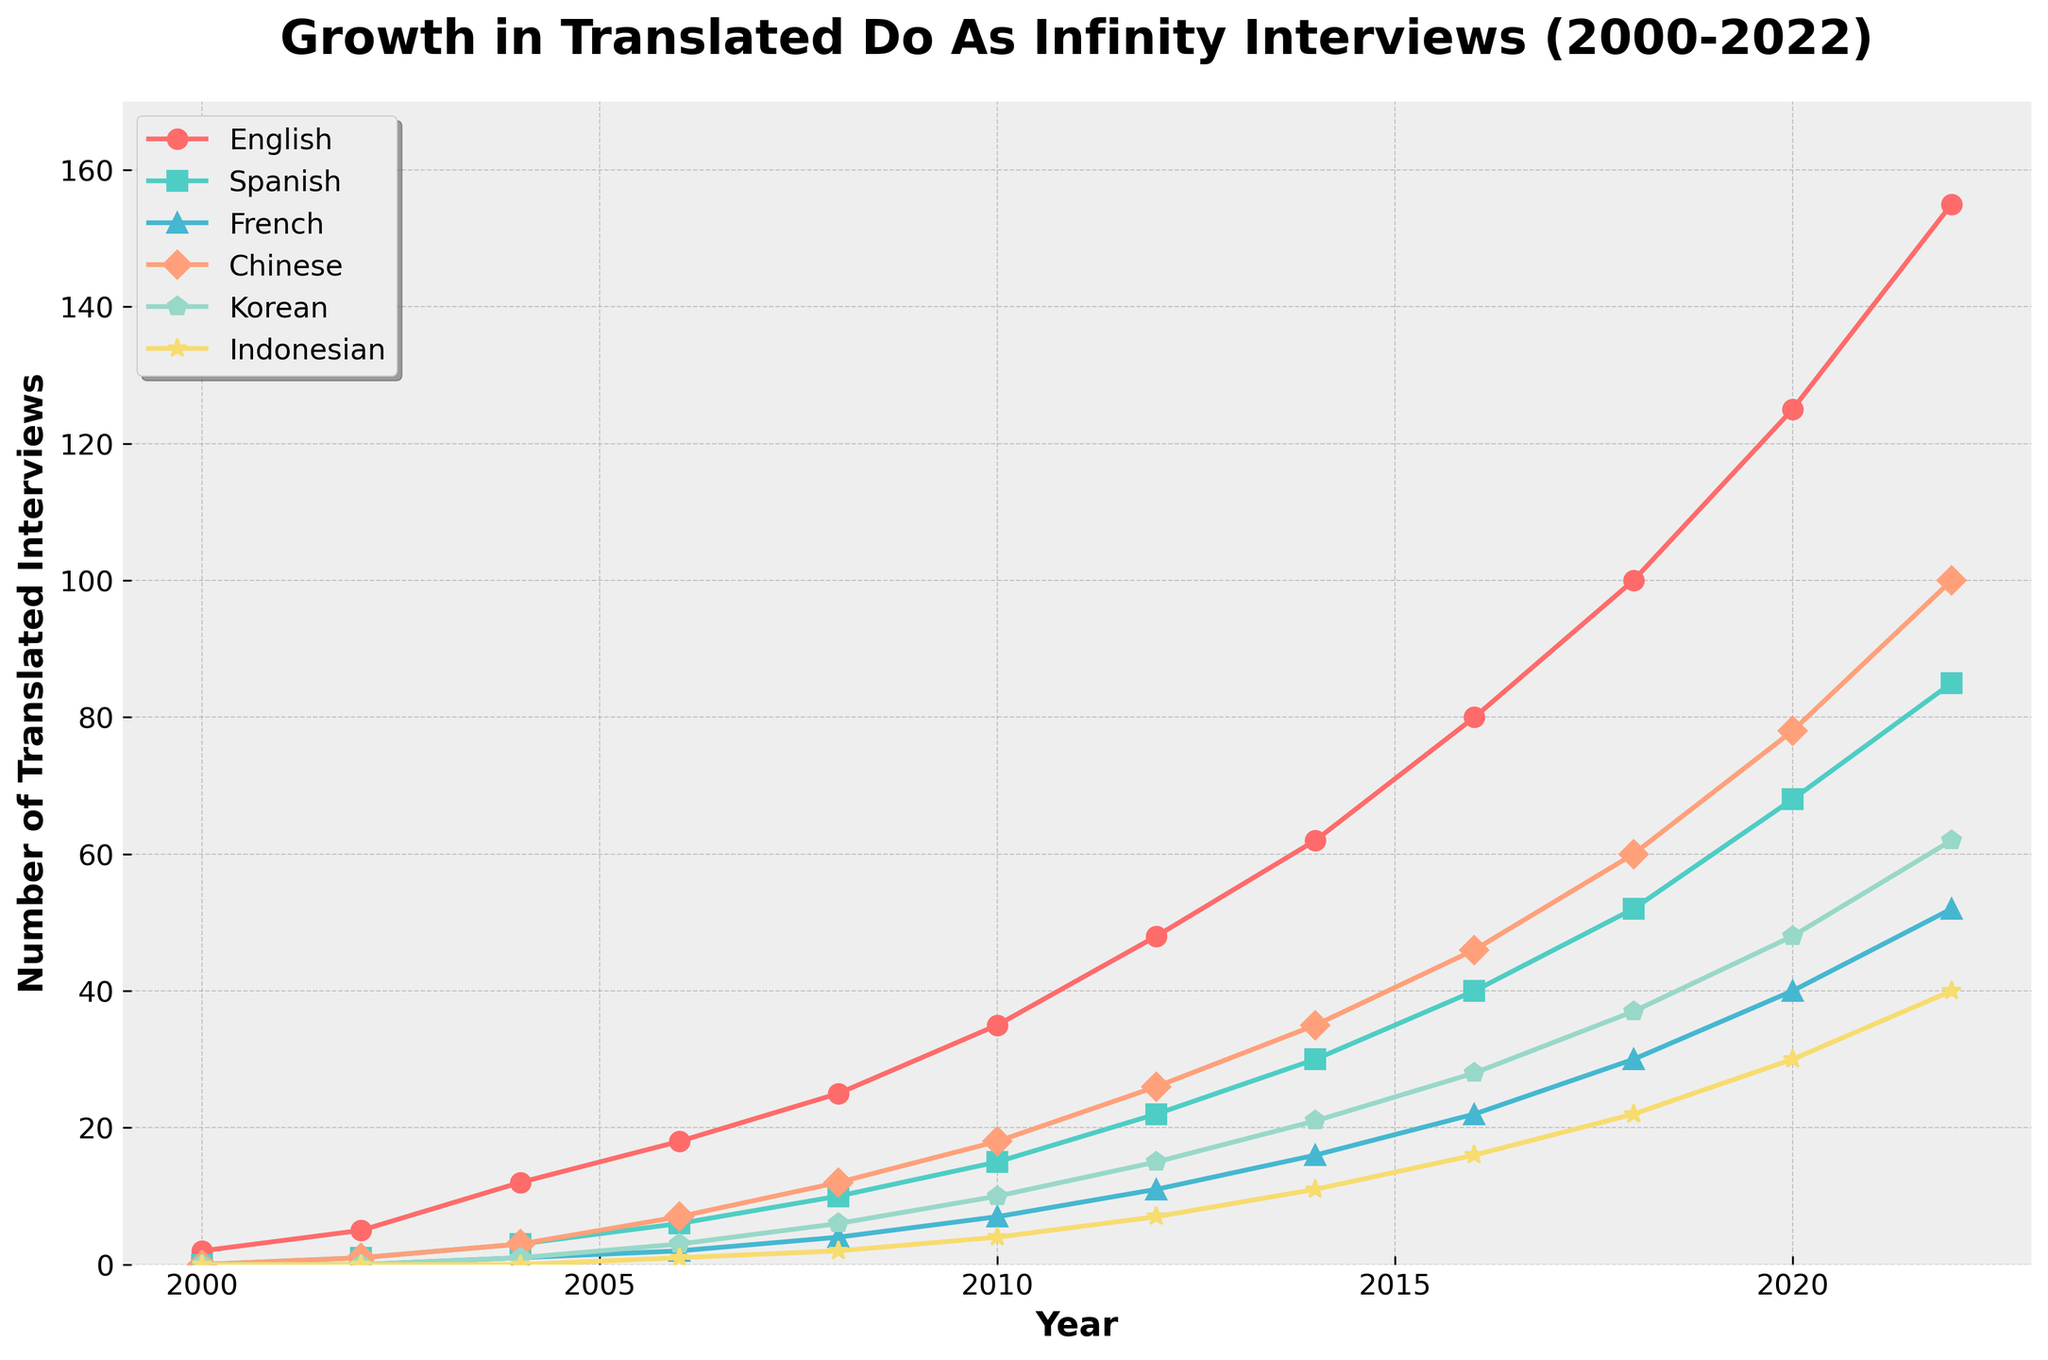How many translated interviews were available in English in 2022? Look at the value of the English series in the year 2022. The number is 155.
Answer: 155 In which year did the Korean translations first surpass 20? Identify the point where the Korean series surpasses the value of 20. This happens in 2016.
Answer: 2016 Which language saw the fastest growth between 2010 and 2020? Compare the changes in the number of translated interviews between 2010 and 2020 for each language. English went from 35 to 125, a gain of 90. Spanish went from 15 to 68, a gain of 53. French went from 7 to 40, a gain of 33. Chinese went from 18 to 78, a gain of 60. Korean went from 10 to 48, a gain of 38. Indonesian went from 4 to 30, a gain of 26. Therefore, English saw the fastest growth with an increase of 90.
Answer: English How many total translated interviews were there in 2006 across all languages? Sum the values for all languages in 2006. These values are 18 (English), 6 (Spanish), 2 (French), 7 (Chinese), 3 (Korean), and 1 (Indonesian). The total is 18 + 6 + 2 + 7 + 3 + 1 = 37.
Answer: 37 When did the total number of Spanish and French translations first exceed 50? Sum the Spanish and French translations for each year and find when the total first exceeds 50. In 2012: 22 (Spanish) + 11 (French) = 33; In 2014: 30 (Spanish) + 16 (French) = 46; In 2016: 40 (Spanish) + 22 (French) = 62. Thus, the total first exceeds 50 in 2016.
Answer: 2016 What year did the Chinese translations reach 100? Look at the data points for Chinese translations and identify when it first hits 100. This occurs in 2022.
Answer: 2022 Which language had the smallest growth from 2000 to 2006? Calculate the increase in the number of translated interviews from 2000 to 2006 for each language. English: 18 - 2 = 16; Spanish: 6 - 0 = 6; French: 2 - 0 = 2; Chinese: 7 - 0 = 7; Korean: 3 - 0 = 3; Indonesian: 1 - 0 = 1. Therefore, Indonesian had the smallest growth, with an increase of only 1.
Answer: Indonesian By how much did the number of French translated interviews change between 2004 and 2016? Subtract the number of French translations in 2004 from that in 2016. The values are 22 (in 2016) and 1 (in 2004). Thus, the change is 22 - 1 = 21.
Answer: 21 What number of Indonesian translated interviews were available in the year when English reached 100 interviews? Find the year when the English series first hits 100, which is 2018, and then look at the value of the Indonesian series in that year. The value is 22.
Answer: 22 